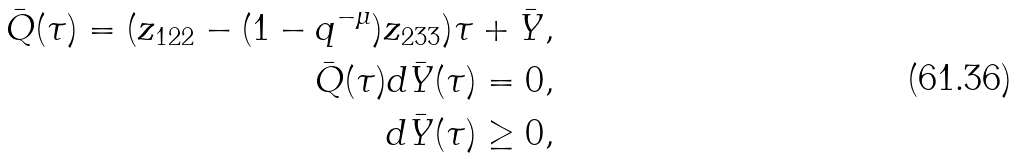<formula> <loc_0><loc_0><loc_500><loc_500>\bar { Q } ( \tau ) = ( z _ { 1 2 2 } - ( 1 - q ^ { - \mu } ) z _ { 2 3 3 } ) \tau + \bar { Y } , \\ \bar { Q } ( \tau ) d \bar { Y } ( \tau ) = 0 , \\ d \bar { Y } ( \tau ) \geq 0 ,</formula> 